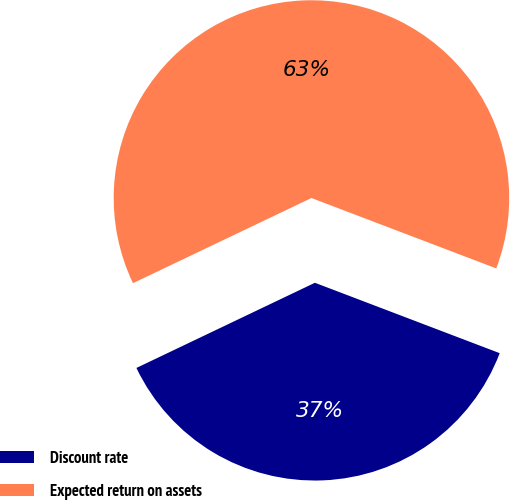Convert chart. <chart><loc_0><loc_0><loc_500><loc_500><pie_chart><fcel>Discount rate<fcel>Expected return on assets<nl><fcel>37.12%<fcel>62.88%<nl></chart> 